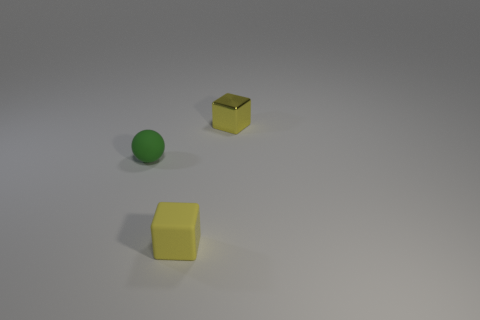Add 3 small red metal objects. How many objects exist? 6 Subtract all balls. How many objects are left? 2 Subtract 0 green cubes. How many objects are left? 3 Subtract all small yellow metallic things. Subtract all small yellow metal things. How many objects are left? 1 Add 1 yellow metallic cubes. How many yellow metallic cubes are left? 2 Add 2 tiny brown metal things. How many tiny brown metal things exist? 2 